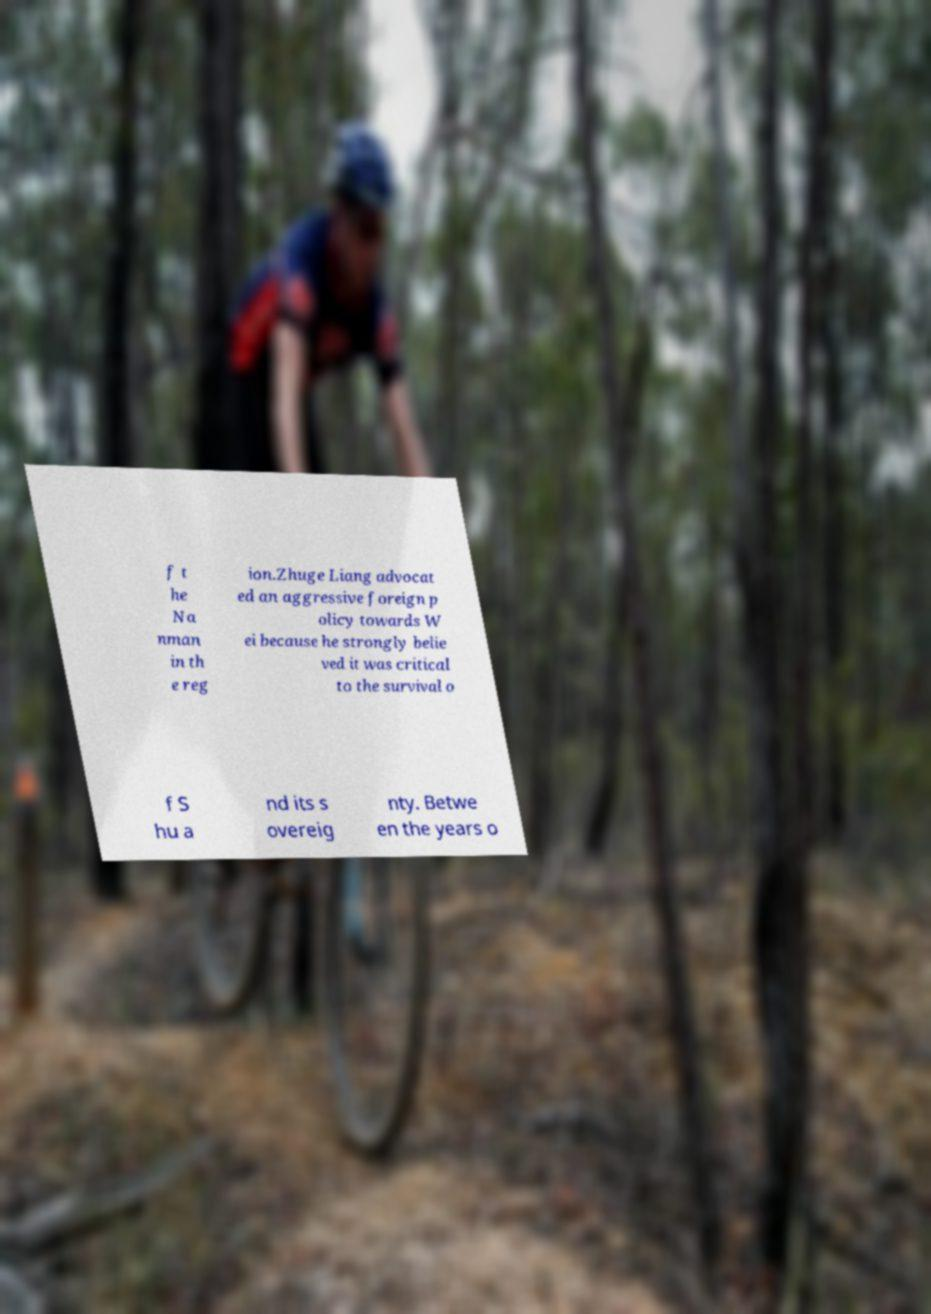What messages or text are displayed in this image? I need them in a readable, typed format. f t he Na nman in th e reg ion.Zhuge Liang advocat ed an aggressive foreign p olicy towards W ei because he strongly belie ved it was critical to the survival o f S hu a nd its s overeig nty. Betwe en the years o 